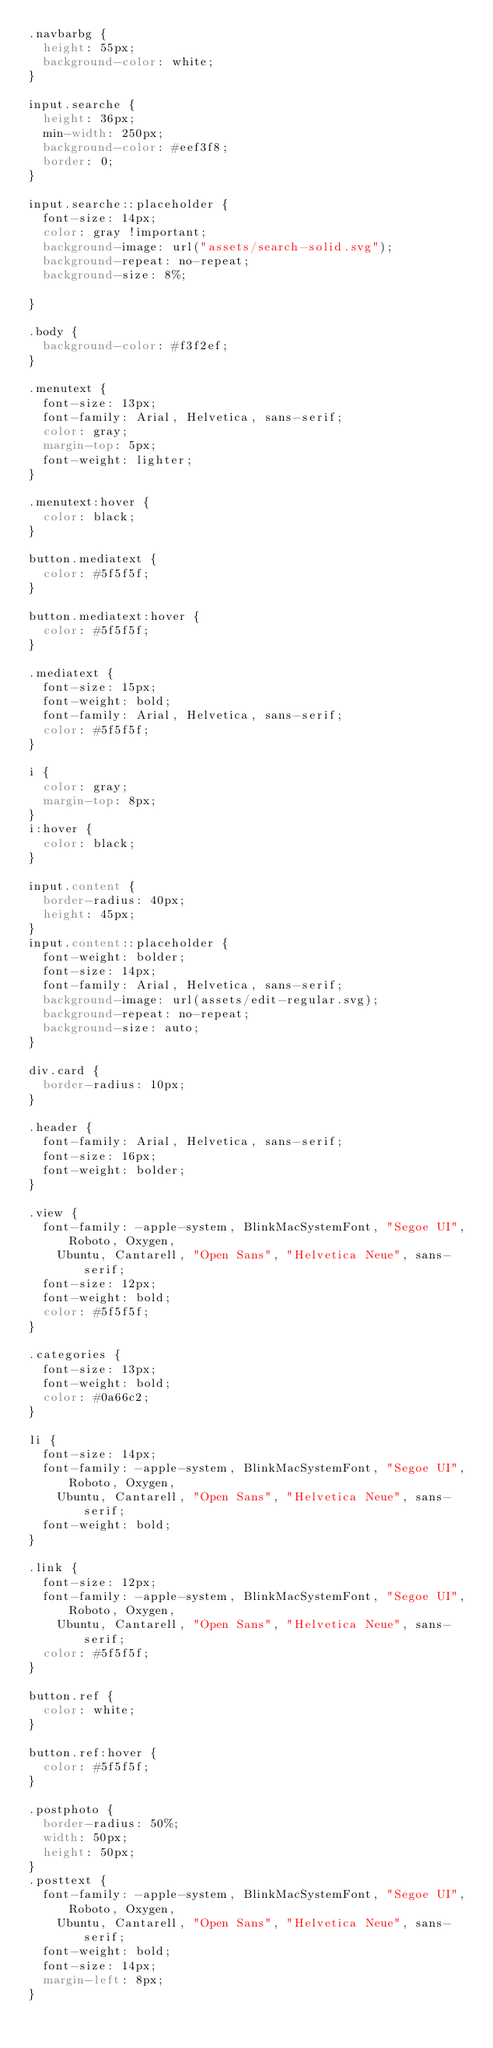Convert code to text. <code><loc_0><loc_0><loc_500><loc_500><_CSS_>.navbarbg {
  height: 55px;
  background-color: white;
}

input.searche {
  height: 36px;
  min-width: 250px;
  background-color: #eef3f8;
  border: 0;
}

input.searche::placeholder {
  font-size: 14px;
  color: gray !important;
  background-image: url("assets/search-solid.svg");
  background-repeat: no-repeat;
  background-size: 8%;

}

.body {
  background-color: #f3f2ef;
}

.menutext {
  font-size: 13px;
  font-family: Arial, Helvetica, sans-serif;
  color: gray;
  margin-top: 5px;
  font-weight: lighter;
}

.menutext:hover {
  color: black;
}

button.mediatext {
  color: #5f5f5f;
}

button.mediatext:hover {
  color: #5f5f5f;
}

.mediatext {
  font-size: 15px;
  font-weight: bold;
  font-family: Arial, Helvetica, sans-serif;
  color: #5f5f5f;
}

i {
  color: gray;
  margin-top: 8px;
}
i:hover {
  color: black;
}

input.content {
  border-radius: 40px;
  height: 45px;
}
input.content::placeholder {
  font-weight: bolder;
  font-size: 14px;
  font-family: Arial, Helvetica, sans-serif;
  background-image: url(assets/edit-regular.svg);
  background-repeat: no-repeat;
  background-size: auto;
}

div.card {
  border-radius: 10px;
}

.header {
  font-family: Arial, Helvetica, sans-serif;
  font-size: 16px;
  font-weight: bolder;
}

.view {
  font-family: -apple-system, BlinkMacSystemFont, "Segoe UI", Roboto, Oxygen,
    Ubuntu, Cantarell, "Open Sans", "Helvetica Neue", sans-serif;
  font-size: 12px;
  font-weight: bold;
  color: #5f5f5f;
}

.categories {
  font-size: 13px;
  font-weight: bold;
  color: #0a66c2;
}

li {
  font-size: 14px;
  font-family: -apple-system, BlinkMacSystemFont, "Segoe UI", Roboto, Oxygen,
    Ubuntu, Cantarell, "Open Sans", "Helvetica Neue", sans-serif;
  font-weight: bold;
}

.link {
  font-size: 12px;
  font-family: -apple-system, BlinkMacSystemFont, "Segoe UI", Roboto, Oxygen,
    Ubuntu, Cantarell, "Open Sans", "Helvetica Neue", sans-serif;
  color: #5f5f5f;
}

button.ref {
  color: white;
}

button.ref:hover {
  color: #5f5f5f;
}

.postphoto {
  border-radius: 50%;
  width: 50px;
  height: 50px;
}
.posttext {
  font-family: -apple-system, BlinkMacSystemFont, "Segoe UI", Roboto, Oxygen,
    Ubuntu, Cantarell, "Open Sans", "Helvetica Neue", sans-serif;
  font-weight: bold;
  font-size: 14px;
  margin-left: 8px;
}</code> 